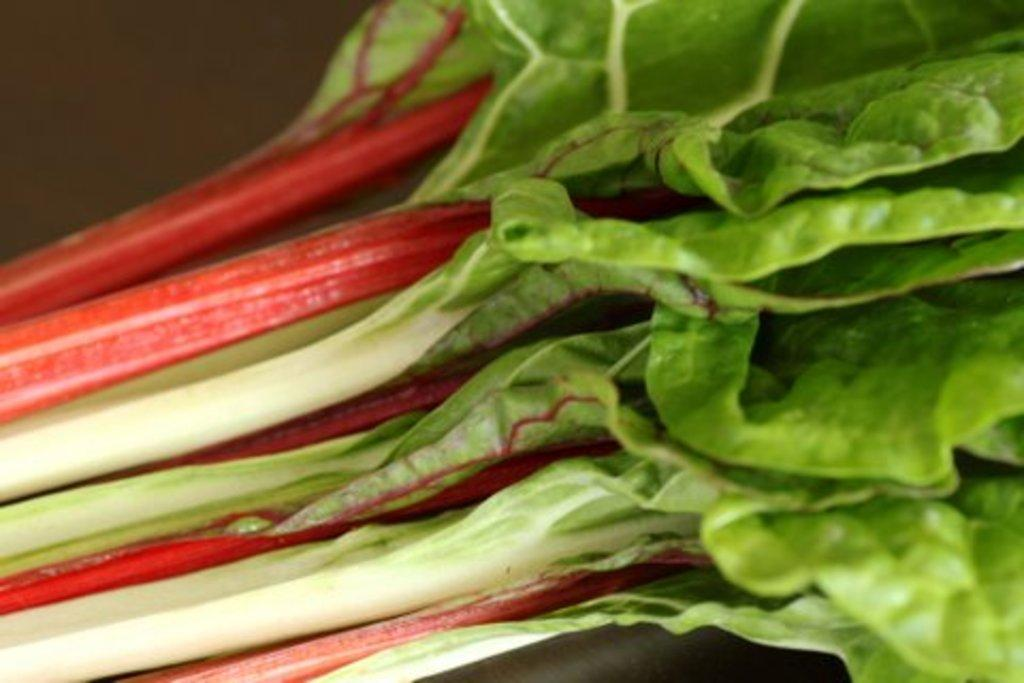What color are the leaves in the image? The leaves in the image are green. What type of education can be seen in the image? There is no reference to education in the image; it only features green color leaves. What kind of shoes are visible in the image? There are no shoes present in the image; it only features green color leaves. 